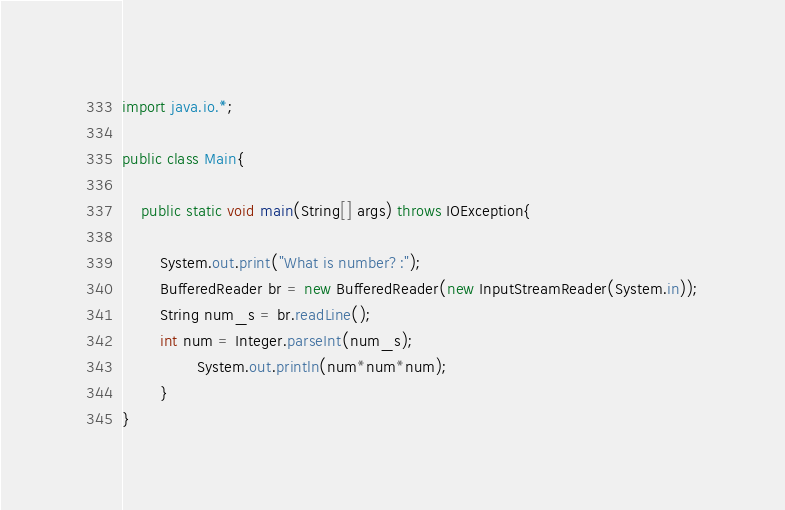<code> <loc_0><loc_0><loc_500><loc_500><_Java_>import java.io.*;

public class Main{
	
	public static void main(String[] args) throws IOException{
		
		System.out.print("What is number?:");
		BufferedReader br = new BufferedReader(new InputStreamReader(System.in));
		String num_s = br.readLine();
		int num = Integer.parseInt(num_s);
                System.out.println(num*num*num);
        }
}</code> 